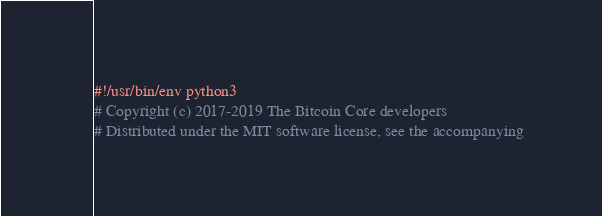Convert code to text. <code><loc_0><loc_0><loc_500><loc_500><_Python_>#!/usr/bin/env python3
# Copyright (c) 2017-2019 The Bitcoin Core developers
# Distributed under the MIT software license, see the accompanying</code> 